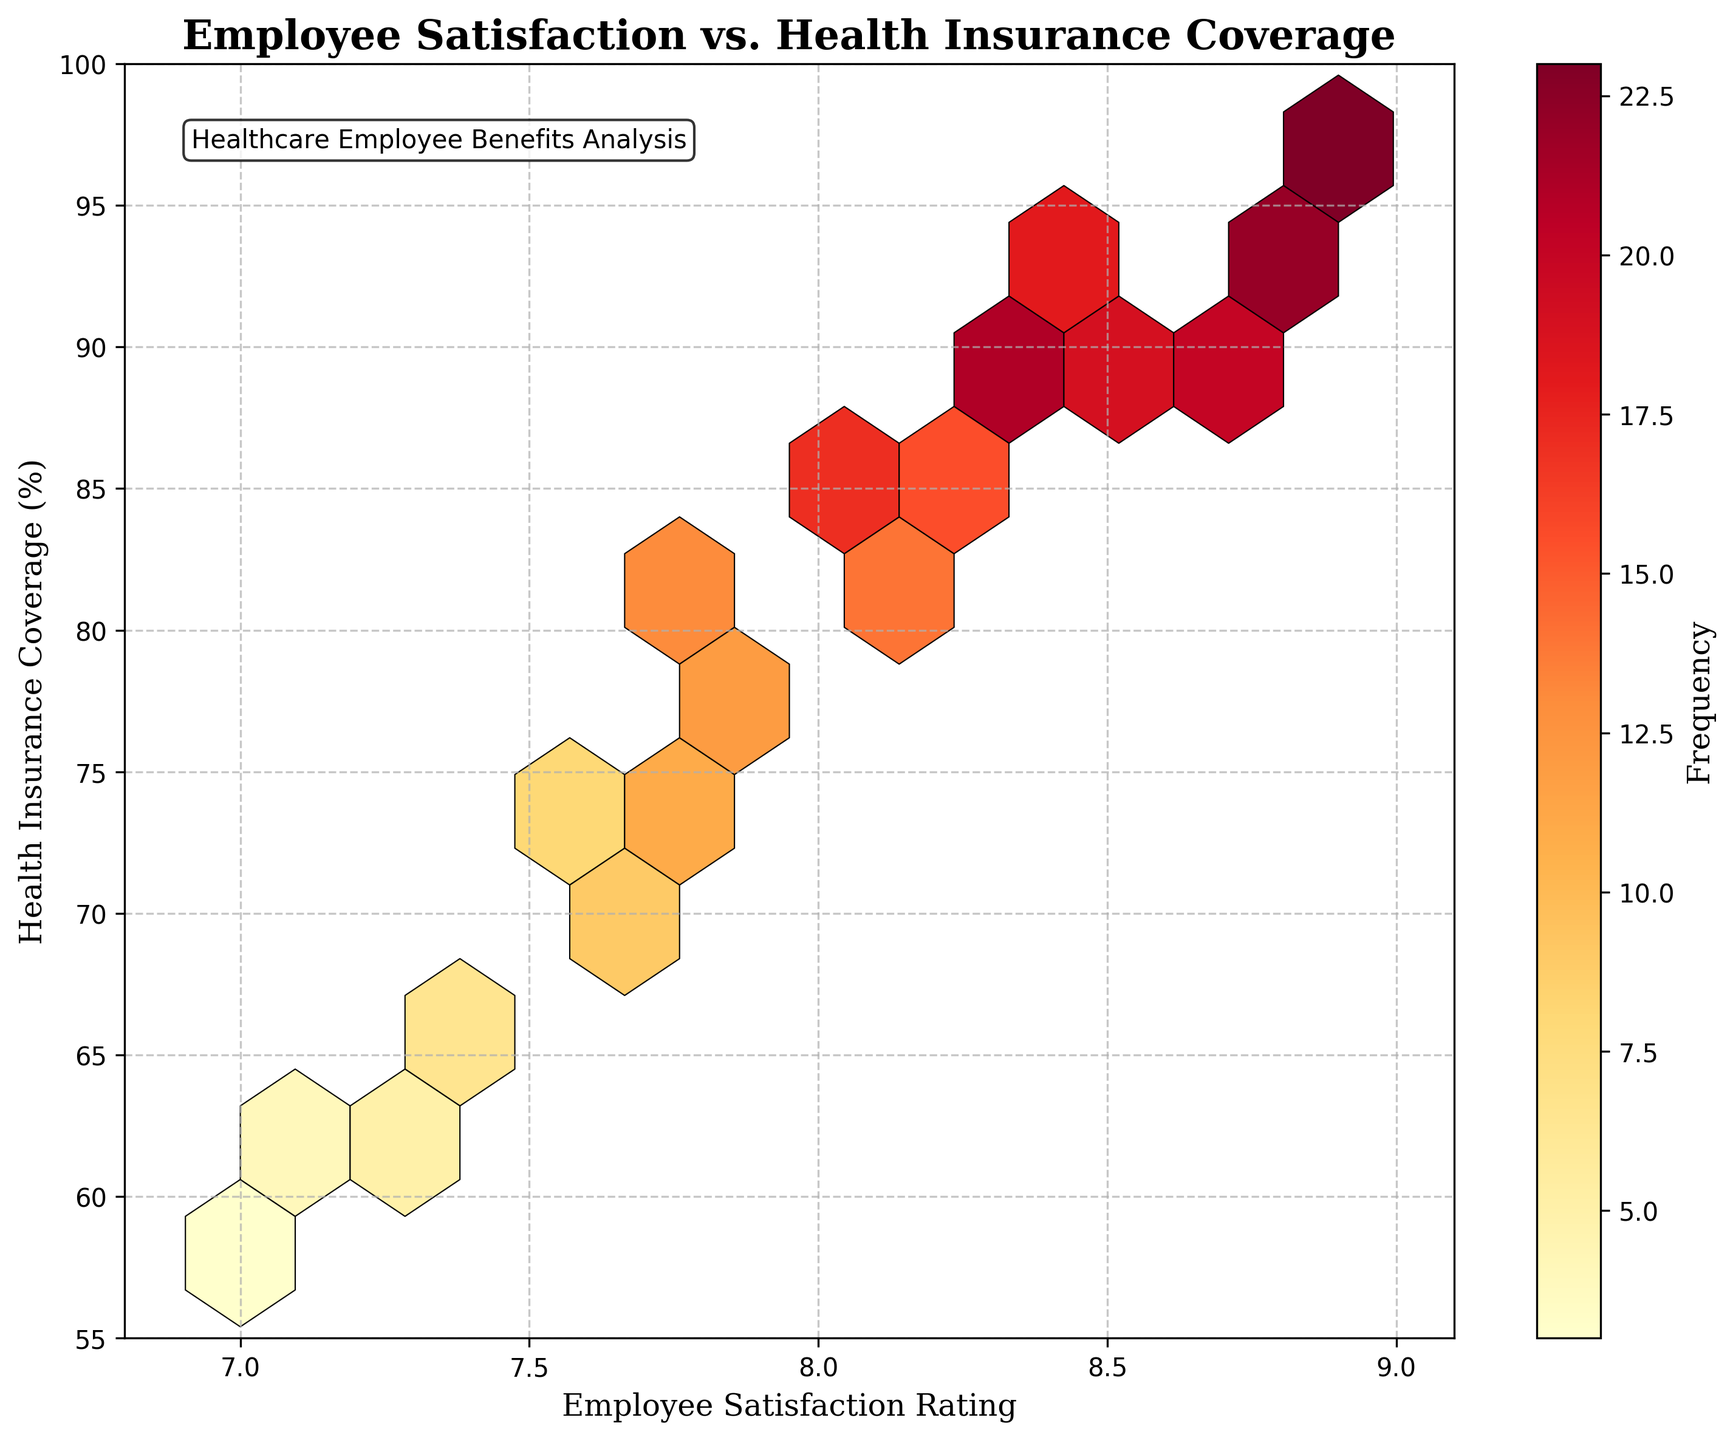What is the title of the plot? The title is placed at the top center of the figure. It reads "Employee Satisfaction vs. Health Insurance Coverage".
Answer: Employee Satisfaction vs. Health Insurance Coverage What do the x-axis and y-axis represent? The labels of the x-axis and y-axis can be read. The x-axis represents "Employee Satisfaction Rating", and the y-axis represents "Health Insurance Coverage (%)".
Answer: Employee Satisfaction Rating, Health Insurance Coverage (%) Where are the densest areas of data points in the plot? The color intensity indicates density. The densest areas are reflected by the darkest colors in the bin cells, which are around coordinates (8.5, 92) and (8.9, 97).
Answer: Around (8.5, 92) and (8.9, 97) Which satisfaction rating has the highest range of health insurance coverage in the plot? By looking at the horizontal range covered by the hexes corresponding to each satisfaction rating, the rating of 8.4 has coverage points that span widely from 82% to 89%.
Answer: 8.4 Which area of the plot signifies the lowest satisfaction ratings and coverage percentages? The corners with the lightest or absent hexes indicate lower frequencies. For instance, the bottom-left corner has light colors, specifically around (7.0, 58).
Answer: Around (7.0, 58) What is the frequency of the data point with satisfaction rating 8.8 and coverage 95%? By observing the color bars and labels, we see that around (8.8, 95), the hexagon color indicates high frequency, precisely 22 as per the tabulated data.
Answer: 22 Compare the employee satisfaction rating of 8.0 with coverage 84% and 7.8 with coverage 80%. Which has higher frequency? Check the colors of the hexagons corresponding to these coordinates. The frequency for (8.0, 84) is reflected as 17, whereas (7.8, 80) shows 13.
Answer: 8.0 with coverage 84% What information does the colorbar convey in the plot? It shows the frequency of occurrences of employee satisfaction ratings and healthcare coverage percentages. Darker colors indicate higher frequencies.
Answer: Frequency of occurrences Is there a general trend between employee satisfaction and health insurance coverage? Observe how the data points are distributed. There's a slight upward trend suggesting that higher satisfaction ratings tend to be associated with higher insurance coverage percentages.
Answer: Higher satisfaction correlates with higher coverage What's the coverage percentage at the satisfaction rating with the median for the entire dataset? Counting the ratings, the median falls between 8.0 and 8.1. The coverage percentages corresponding approximately are around 84% for 8.0 and 82% for 8.1.
Answer: Around 83% 